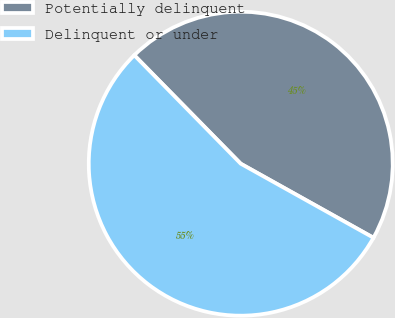Convert chart to OTSL. <chart><loc_0><loc_0><loc_500><loc_500><pie_chart><fcel>Potentially delinquent<fcel>Delinquent or under<nl><fcel>45.45%<fcel>54.55%<nl></chart> 